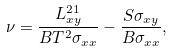Convert formula to latex. <formula><loc_0><loc_0><loc_500><loc_500>\nu = \frac { L ^ { 2 1 } _ { x y } } { B T ^ { 2 } \sigma _ { x x } } - \frac { S \sigma _ { x y } } { B \sigma _ { x x } } ,</formula> 